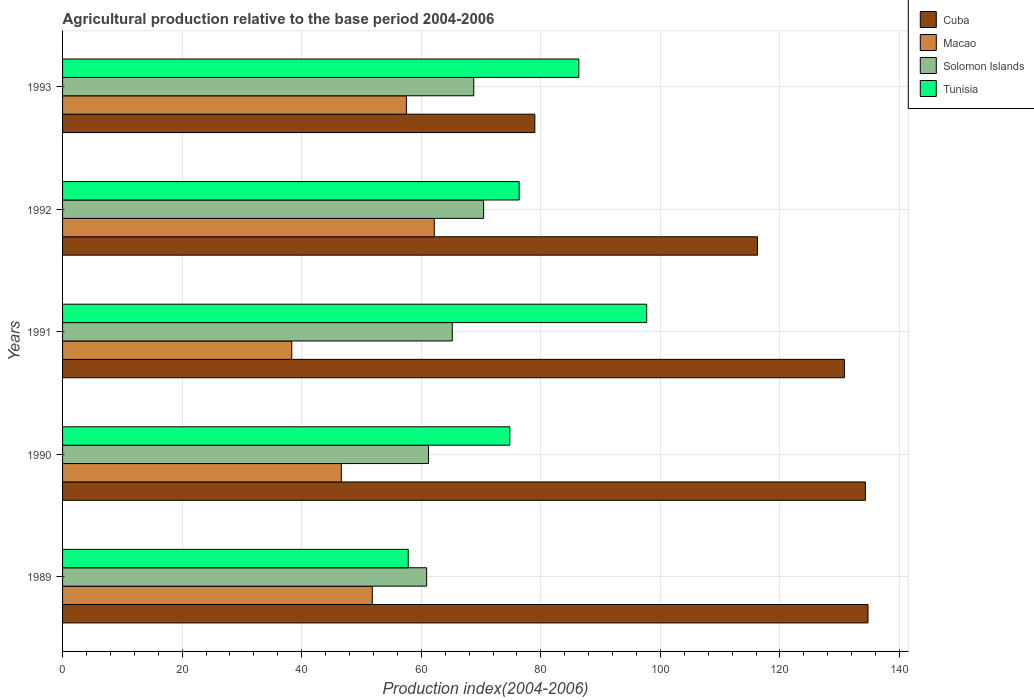Are the number of bars per tick equal to the number of legend labels?
Keep it short and to the point. Yes. Are the number of bars on each tick of the Y-axis equal?
Provide a succinct answer. Yes. How many bars are there on the 5th tick from the top?
Make the answer very short. 4. What is the label of the 3rd group of bars from the top?
Ensure brevity in your answer.  1991. What is the agricultural production index in Macao in 1989?
Give a very brief answer. 51.81. Across all years, what is the maximum agricultural production index in Macao?
Make the answer very short. 62.18. Across all years, what is the minimum agricultural production index in Macao?
Offer a very short reply. 38.34. What is the total agricultural production index in Macao in the graph?
Your answer should be very brief. 256.47. What is the difference between the agricultural production index in Macao in 1990 and that in 1991?
Give a very brief answer. 8.29. What is the difference between the agricultural production index in Cuba in 1990 and the agricultural production index in Tunisia in 1992?
Keep it short and to the point. 57.91. What is the average agricultural production index in Cuba per year?
Give a very brief answer. 119.01. In the year 1993, what is the difference between the agricultural production index in Tunisia and agricultural production index in Cuba?
Provide a succinct answer. 7.36. What is the ratio of the agricultural production index in Cuba in 1991 to that in 1992?
Your response must be concise. 1.13. What is the difference between the highest and the second highest agricultural production index in Tunisia?
Offer a terse response. 11.35. What is the difference between the highest and the lowest agricultural production index in Tunisia?
Offer a very short reply. 39.88. Is it the case that in every year, the sum of the agricultural production index in Tunisia and agricultural production index in Cuba is greater than the sum of agricultural production index in Solomon Islands and agricultural production index in Macao?
Offer a terse response. No. What does the 4th bar from the top in 1993 represents?
Your answer should be very brief. Cuba. What does the 2nd bar from the bottom in 1992 represents?
Your response must be concise. Macao. How many years are there in the graph?
Your answer should be very brief. 5. Are the values on the major ticks of X-axis written in scientific E-notation?
Make the answer very short. No. Does the graph contain any zero values?
Provide a succinct answer. No. Does the graph contain grids?
Your answer should be compact. Yes. What is the title of the graph?
Keep it short and to the point. Agricultural production relative to the base period 2004-2006. Does "Low income" appear as one of the legend labels in the graph?
Your response must be concise. No. What is the label or title of the X-axis?
Provide a succinct answer. Production index(2004-2006). What is the label or title of the Y-axis?
Provide a short and direct response. Years. What is the Production index(2004-2006) in Cuba in 1989?
Make the answer very short. 134.73. What is the Production index(2004-2006) of Macao in 1989?
Your answer should be compact. 51.81. What is the Production index(2004-2006) in Solomon Islands in 1989?
Give a very brief answer. 60.9. What is the Production index(2004-2006) in Tunisia in 1989?
Your answer should be compact. 57.83. What is the Production index(2004-2006) in Cuba in 1990?
Your answer should be very brief. 134.29. What is the Production index(2004-2006) in Macao in 1990?
Your answer should be compact. 46.63. What is the Production index(2004-2006) in Solomon Islands in 1990?
Offer a terse response. 61.21. What is the Production index(2004-2006) of Tunisia in 1990?
Your answer should be very brief. 74.82. What is the Production index(2004-2006) of Cuba in 1991?
Provide a short and direct response. 130.78. What is the Production index(2004-2006) of Macao in 1991?
Keep it short and to the point. 38.34. What is the Production index(2004-2006) in Solomon Islands in 1991?
Offer a very short reply. 65.19. What is the Production index(2004-2006) of Tunisia in 1991?
Your answer should be very brief. 97.71. What is the Production index(2004-2006) of Cuba in 1992?
Provide a short and direct response. 116.24. What is the Production index(2004-2006) in Macao in 1992?
Ensure brevity in your answer.  62.18. What is the Production index(2004-2006) of Solomon Islands in 1992?
Make the answer very short. 70.43. What is the Production index(2004-2006) in Tunisia in 1992?
Provide a succinct answer. 76.38. What is the Production index(2004-2006) of Cuba in 1993?
Give a very brief answer. 79. What is the Production index(2004-2006) in Macao in 1993?
Offer a very short reply. 57.51. What is the Production index(2004-2006) of Solomon Islands in 1993?
Offer a very short reply. 68.78. What is the Production index(2004-2006) in Tunisia in 1993?
Ensure brevity in your answer.  86.36. Across all years, what is the maximum Production index(2004-2006) in Cuba?
Your response must be concise. 134.73. Across all years, what is the maximum Production index(2004-2006) in Macao?
Offer a very short reply. 62.18. Across all years, what is the maximum Production index(2004-2006) of Solomon Islands?
Your response must be concise. 70.43. Across all years, what is the maximum Production index(2004-2006) in Tunisia?
Your response must be concise. 97.71. Across all years, what is the minimum Production index(2004-2006) of Cuba?
Provide a succinct answer. 79. Across all years, what is the minimum Production index(2004-2006) in Macao?
Your response must be concise. 38.34. Across all years, what is the minimum Production index(2004-2006) of Solomon Islands?
Your answer should be very brief. 60.9. Across all years, what is the minimum Production index(2004-2006) of Tunisia?
Your response must be concise. 57.83. What is the total Production index(2004-2006) in Cuba in the graph?
Your response must be concise. 595.04. What is the total Production index(2004-2006) of Macao in the graph?
Ensure brevity in your answer.  256.47. What is the total Production index(2004-2006) of Solomon Islands in the graph?
Give a very brief answer. 326.51. What is the total Production index(2004-2006) in Tunisia in the graph?
Give a very brief answer. 393.1. What is the difference between the Production index(2004-2006) in Cuba in 1989 and that in 1990?
Make the answer very short. 0.44. What is the difference between the Production index(2004-2006) of Macao in 1989 and that in 1990?
Provide a succinct answer. 5.18. What is the difference between the Production index(2004-2006) of Solomon Islands in 1989 and that in 1990?
Your response must be concise. -0.31. What is the difference between the Production index(2004-2006) in Tunisia in 1989 and that in 1990?
Provide a short and direct response. -16.99. What is the difference between the Production index(2004-2006) of Cuba in 1989 and that in 1991?
Offer a very short reply. 3.95. What is the difference between the Production index(2004-2006) in Macao in 1989 and that in 1991?
Ensure brevity in your answer.  13.47. What is the difference between the Production index(2004-2006) of Solomon Islands in 1989 and that in 1991?
Offer a terse response. -4.29. What is the difference between the Production index(2004-2006) of Tunisia in 1989 and that in 1991?
Your response must be concise. -39.88. What is the difference between the Production index(2004-2006) of Cuba in 1989 and that in 1992?
Make the answer very short. 18.49. What is the difference between the Production index(2004-2006) in Macao in 1989 and that in 1992?
Give a very brief answer. -10.37. What is the difference between the Production index(2004-2006) of Solomon Islands in 1989 and that in 1992?
Make the answer very short. -9.53. What is the difference between the Production index(2004-2006) in Tunisia in 1989 and that in 1992?
Keep it short and to the point. -18.55. What is the difference between the Production index(2004-2006) of Cuba in 1989 and that in 1993?
Make the answer very short. 55.73. What is the difference between the Production index(2004-2006) of Solomon Islands in 1989 and that in 1993?
Provide a succinct answer. -7.88. What is the difference between the Production index(2004-2006) of Tunisia in 1989 and that in 1993?
Make the answer very short. -28.53. What is the difference between the Production index(2004-2006) in Cuba in 1990 and that in 1991?
Your response must be concise. 3.51. What is the difference between the Production index(2004-2006) in Macao in 1990 and that in 1991?
Offer a very short reply. 8.29. What is the difference between the Production index(2004-2006) in Solomon Islands in 1990 and that in 1991?
Your answer should be compact. -3.98. What is the difference between the Production index(2004-2006) of Tunisia in 1990 and that in 1991?
Offer a terse response. -22.89. What is the difference between the Production index(2004-2006) in Cuba in 1990 and that in 1992?
Ensure brevity in your answer.  18.05. What is the difference between the Production index(2004-2006) in Macao in 1990 and that in 1992?
Give a very brief answer. -15.55. What is the difference between the Production index(2004-2006) of Solomon Islands in 1990 and that in 1992?
Provide a succinct answer. -9.22. What is the difference between the Production index(2004-2006) of Tunisia in 1990 and that in 1992?
Your answer should be very brief. -1.56. What is the difference between the Production index(2004-2006) of Cuba in 1990 and that in 1993?
Make the answer very short. 55.29. What is the difference between the Production index(2004-2006) of Macao in 1990 and that in 1993?
Keep it short and to the point. -10.88. What is the difference between the Production index(2004-2006) in Solomon Islands in 1990 and that in 1993?
Ensure brevity in your answer.  -7.57. What is the difference between the Production index(2004-2006) in Tunisia in 1990 and that in 1993?
Make the answer very short. -11.54. What is the difference between the Production index(2004-2006) in Cuba in 1991 and that in 1992?
Offer a very short reply. 14.54. What is the difference between the Production index(2004-2006) in Macao in 1991 and that in 1992?
Provide a succinct answer. -23.84. What is the difference between the Production index(2004-2006) of Solomon Islands in 1991 and that in 1992?
Your answer should be very brief. -5.24. What is the difference between the Production index(2004-2006) of Tunisia in 1991 and that in 1992?
Keep it short and to the point. 21.33. What is the difference between the Production index(2004-2006) of Cuba in 1991 and that in 1993?
Provide a succinct answer. 51.78. What is the difference between the Production index(2004-2006) of Macao in 1991 and that in 1993?
Give a very brief answer. -19.17. What is the difference between the Production index(2004-2006) in Solomon Islands in 1991 and that in 1993?
Your answer should be compact. -3.59. What is the difference between the Production index(2004-2006) in Tunisia in 1991 and that in 1993?
Ensure brevity in your answer.  11.35. What is the difference between the Production index(2004-2006) of Cuba in 1992 and that in 1993?
Provide a short and direct response. 37.24. What is the difference between the Production index(2004-2006) in Macao in 1992 and that in 1993?
Keep it short and to the point. 4.67. What is the difference between the Production index(2004-2006) in Solomon Islands in 1992 and that in 1993?
Your answer should be very brief. 1.65. What is the difference between the Production index(2004-2006) in Tunisia in 1992 and that in 1993?
Give a very brief answer. -9.98. What is the difference between the Production index(2004-2006) of Cuba in 1989 and the Production index(2004-2006) of Macao in 1990?
Give a very brief answer. 88.1. What is the difference between the Production index(2004-2006) in Cuba in 1989 and the Production index(2004-2006) in Solomon Islands in 1990?
Provide a short and direct response. 73.52. What is the difference between the Production index(2004-2006) of Cuba in 1989 and the Production index(2004-2006) of Tunisia in 1990?
Your response must be concise. 59.91. What is the difference between the Production index(2004-2006) of Macao in 1989 and the Production index(2004-2006) of Solomon Islands in 1990?
Make the answer very short. -9.4. What is the difference between the Production index(2004-2006) in Macao in 1989 and the Production index(2004-2006) in Tunisia in 1990?
Offer a very short reply. -23.01. What is the difference between the Production index(2004-2006) in Solomon Islands in 1989 and the Production index(2004-2006) in Tunisia in 1990?
Ensure brevity in your answer.  -13.92. What is the difference between the Production index(2004-2006) in Cuba in 1989 and the Production index(2004-2006) in Macao in 1991?
Make the answer very short. 96.39. What is the difference between the Production index(2004-2006) in Cuba in 1989 and the Production index(2004-2006) in Solomon Islands in 1991?
Offer a very short reply. 69.54. What is the difference between the Production index(2004-2006) of Cuba in 1989 and the Production index(2004-2006) of Tunisia in 1991?
Give a very brief answer. 37.02. What is the difference between the Production index(2004-2006) of Macao in 1989 and the Production index(2004-2006) of Solomon Islands in 1991?
Ensure brevity in your answer.  -13.38. What is the difference between the Production index(2004-2006) of Macao in 1989 and the Production index(2004-2006) of Tunisia in 1991?
Provide a succinct answer. -45.9. What is the difference between the Production index(2004-2006) in Solomon Islands in 1989 and the Production index(2004-2006) in Tunisia in 1991?
Offer a terse response. -36.81. What is the difference between the Production index(2004-2006) in Cuba in 1989 and the Production index(2004-2006) in Macao in 1992?
Your answer should be very brief. 72.55. What is the difference between the Production index(2004-2006) in Cuba in 1989 and the Production index(2004-2006) in Solomon Islands in 1992?
Keep it short and to the point. 64.3. What is the difference between the Production index(2004-2006) in Cuba in 1989 and the Production index(2004-2006) in Tunisia in 1992?
Your answer should be compact. 58.35. What is the difference between the Production index(2004-2006) in Macao in 1989 and the Production index(2004-2006) in Solomon Islands in 1992?
Your answer should be very brief. -18.62. What is the difference between the Production index(2004-2006) of Macao in 1989 and the Production index(2004-2006) of Tunisia in 1992?
Your response must be concise. -24.57. What is the difference between the Production index(2004-2006) of Solomon Islands in 1989 and the Production index(2004-2006) of Tunisia in 1992?
Provide a short and direct response. -15.48. What is the difference between the Production index(2004-2006) in Cuba in 1989 and the Production index(2004-2006) in Macao in 1993?
Your response must be concise. 77.22. What is the difference between the Production index(2004-2006) in Cuba in 1989 and the Production index(2004-2006) in Solomon Islands in 1993?
Make the answer very short. 65.95. What is the difference between the Production index(2004-2006) in Cuba in 1989 and the Production index(2004-2006) in Tunisia in 1993?
Ensure brevity in your answer.  48.37. What is the difference between the Production index(2004-2006) of Macao in 1989 and the Production index(2004-2006) of Solomon Islands in 1993?
Keep it short and to the point. -16.97. What is the difference between the Production index(2004-2006) of Macao in 1989 and the Production index(2004-2006) of Tunisia in 1993?
Your answer should be compact. -34.55. What is the difference between the Production index(2004-2006) in Solomon Islands in 1989 and the Production index(2004-2006) in Tunisia in 1993?
Your answer should be very brief. -25.46. What is the difference between the Production index(2004-2006) of Cuba in 1990 and the Production index(2004-2006) of Macao in 1991?
Provide a succinct answer. 95.95. What is the difference between the Production index(2004-2006) of Cuba in 1990 and the Production index(2004-2006) of Solomon Islands in 1991?
Keep it short and to the point. 69.1. What is the difference between the Production index(2004-2006) in Cuba in 1990 and the Production index(2004-2006) in Tunisia in 1991?
Your response must be concise. 36.58. What is the difference between the Production index(2004-2006) in Macao in 1990 and the Production index(2004-2006) in Solomon Islands in 1991?
Offer a terse response. -18.56. What is the difference between the Production index(2004-2006) of Macao in 1990 and the Production index(2004-2006) of Tunisia in 1991?
Provide a succinct answer. -51.08. What is the difference between the Production index(2004-2006) in Solomon Islands in 1990 and the Production index(2004-2006) in Tunisia in 1991?
Provide a succinct answer. -36.5. What is the difference between the Production index(2004-2006) in Cuba in 1990 and the Production index(2004-2006) in Macao in 1992?
Give a very brief answer. 72.11. What is the difference between the Production index(2004-2006) in Cuba in 1990 and the Production index(2004-2006) in Solomon Islands in 1992?
Provide a short and direct response. 63.86. What is the difference between the Production index(2004-2006) of Cuba in 1990 and the Production index(2004-2006) of Tunisia in 1992?
Keep it short and to the point. 57.91. What is the difference between the Production index(2004-2006) of Macao in 1990 and the Production index(2004-2006) of Solomon Islands in 1992?
Offer a very short reply. -23.8. What is the difference between the Production index(2004-2006) of Macao in 1990 and the Production index(2004-2006) of Tunisia in 1992?
Provide a succinct answer. -29.75. What is the difference between the Production index(2004-2006) of Solomon Islands in 1990 and the Production index(2004-2006) of Tunisia in 1992?
Provide a succinct answer. -15.17. What is the difference between the Production index(2004-2006) in Cuba in 1990 and the Production index(2004-2006) in Macao in 1993?
Provide a succinct answer. 76.78. What is the difference between the Production index(2004-2006) of Cuba in 1990 and the Production index(2004-2006) of Solomon Islands in 1993?
Offer a terse response. 65.51. What is the difference between the Production index(2004-2006) in Cuba in 1990 and the Production index(2004-2006) in Tunisia in 1993?
Ensure brevity in your answer.  47.93. What is the difference between the Production index(2004-2006) of Macao in 1990 and the Production index(2004-2006) of Solomon Islands in 1993?
Your response must be concise. -22.15. What is the difference between the Production index(2004-2006) of Macao in 1990 and the Production index(2004-2006) of Tunisia in 1993?
Give a very brief answer. -39.73. What is the difference between the Production index(2004-2006) in Solomon Islands in 1990 and the Production index(2004-2006) in Tunisia in 1993?
Keep it short and to the point. -25.15. What is the difference between the Production index(2004-2006) in Cuba in 1991 and the Production index(2004-2006) in Macao in 1992?
Give a very brief answer. 68.6. What is the difference between the Production index(2004-2006) in Cuba in 1991 and the Production index(2004-2006) in Solomon Islands in 1992?
Give a very brief answer. 60.35. What is the difference between the Production index(2004-2006) in Cuba in 1991 and the Production index(2004-2006) in Tunisia in 1992?
Provide a succinct answer. 54.4. What is the difference between the Production index(2004-2006) of Macao in 1991 and the Production index(2004-2006) of Solomon Islands in 1992?
Your answer should be compact. -32.09. What is the difference between the Production index(2004-2006) of Macao in 1991 and the Production index(2004-2006) of Tunisia in 1992?
Offer a very short reply. -38.04. What is the difference between the Production index(2004-2006) in Solomon Islands in 1991 and the Production index(2004-2006) in Tunisia in 1992?
Make the answer very short. -11.19. What is the difference between the Production index(2004-2006) in Cuba in 1991 and the Production index(2004-2006) in Macao in 1993?
Ensure brevity in your answer.  73.27. What is the difference between the Production index(2004-2006) of Cuba in 1991 and the Production index(2004-2006) of Solomon Islands in 1993?
Provide a short and direct response. 62. What is the difference between the Production index(2004-2006) of Cuba in 1991 and the Production index(2004-2006) of Tunisia in 1993?
Provide a succinct answer. 44.42. What is the difference between the Production index(2004-2006) in Macao in 1991 and the Production index(2004-2006) in Solomon Islands in 1993?
Your response must be concise. -30.44. What is the difference between the Production index(2004-2006) of Macao in 1991 and the Production index(2004-2006) of Tunisia in 1993?
Offer a very short reply. -48.02. What is the difference between the Production index(2004-2006) in Solomon Islands in 1991 and the Production index(2004-2006) in Tunisia in 1993?
Give a very brief answer. -21.17. What is the difference between the Production index(2004-2006) in Cuba in 1992 and the Production index(2004-2006) in Macao in 1993?
Your response must be concise. 58.73. What is the difference between the Production index(2004-2006) in Cuba in 1992 and the Production index(2004-2006) in Solomon Islands in 1993?
Your answer should be very brief. 47.46. What is the difference between the Production index(2004-2006) of Cuba in 1992 and the Production index(2004-2006) of Tunisia in 1993?
Provide a short and direct response. 29.88. What is the difference between the Production index(2004-2006) in Macao in 1992 and the Production index(2004-2006) in Solomon Islands in 1993?
Your answer should be very brief. -6.6. What is the difference between the Production index(2004-2006) in Macao in 1992 and the Production index(2004-2006) in Tunisia in 1993?
Your answer should be very brief. -24.18. What is the difference between the Production index(2004-2006) of Solomon Islands in 1992 and the Production index(2004-2006) of Tunisia in 1993?
Ensure brevity in your answer.  -15.93. What is the average Production index(2004-2006) of Cuba per year?
Your answer should be very brief. 119.01. What is the average Production index(2004-2006) of Macao per year?
Offer a terse response. 51.29. What is the average Production index(2004-2006) in Solomon Islands per year?
Offer a very short reply. 65.3. What is the average Production index(2004-2006) in Tunisia per year?
Make the answer very short. 78.62. In the year 1989, what is the difference between the Production index(2004-2006) in Cuba and Production index(2004-2006) in Macao?
Your response must be concise. 82.92. In the year 1989, what is the difference between the Production index(2004-2006) of Cuba and Production index(2004-2006) of Solomon Islands?
Your answer should be compact. 73.83. In the year 1989, what is the difference between the Production index(2004-2006) in Cuba and Production index(2004-2006) in Tunisia?
Offer a terse response. 76.9. In the year 1989, what is the difference between the Production index(2004-2006) in Macao and Production index(2004-2006) in Solomon Islands?
Provide a short and direct response. -9.09. In the year 1989, what is the difference between the Production index(2004-2006) in Macao and Production index(2004-2006) in Tunisia?
Offer a very short reply. -6.02. In the year 1989, what is the difference between the Production index(2004-2006) in Solomon Islands and Production index(2004-2006) in Tunisia?
Your answer should be compact. 3.07. In the year 1990, what is the difference between the Production index(2004-2006) of Cuba and Production index(2004-2006) of Macao?
Ensure brevity in your answer.  87.66. In the year 1990, what is the difference between the Production index(2004-2006) in Cuba and Production index(2004-2006) in Solomon Islands?
Provide a succinct answer. 73.08. In the year 1990, what is the difference between the Production index(2004-2006) in Cuba and Production index(2004-2006) in Tunisia?
Offer a terse response. 59.47. In the year 1990, what is the difference between the Production index(2004-2006) of Macao and Production index(2004-2006) of Solomon Islands?
Provide a short and direct response. -14.58. In the year 1990, what is the difference between the Production index(2004-2006) of Macao and Production index(2004-2006) of Tunisia?
Give a very brief answer. -28.19. In the year 1990, what is the difference between the Production index(2004-2006) of Solomon Islands and Production index(2004-2006) of Tunisia?
Ensure brevity in your answer.  -13.61. In the year 1991, what is the difference between the Production index(2004-2006) in Cuba and Production index(2004-2006) in Macao?
Offer a very short reply. 92.44. In the year 1991, what is the difference between the Production index(2004-2006) of Cuba and Production index(2004-2006) of Solomon Islands?
Keep it short and to the point. 65.59. In the year 1991, what is the difference between the Production index(2004-2006) of Cuba and Production index(2004-2006) of Tunisia?
Offer a terse response. 33.07. In the year 1991, what is the difference between the Production index(2004-2006) in Macao and Production index(2004-2006) in Solomon Islands?
Your response must be concise. -26.85. In the year 1991, what is the difference between the Production index(2004-2006) of Macao and Production index(2004-2006) of Tunisia?
Your answer should be compact. -59.37. In the year 1991, what is the difference between the Production index(2004-2006) in Solomon Islands and Production index(2004-2006) in Tunisia?
Your answer should be very brief. -32.52. In the year 1992, what is the difference between the Production index(2004-2006) in Cuba and Production index(2004-2006) in Macao?
Provide a succinct answer. 54.06. In the year 1992, what is the difference between the Production index(2004-2006) of Cuba and Production index(2004-2006) of Solomon Islands?
Your answer should be compact. 45.81. In the year 1992, what is the difference between the Production index(2004-2006) of Cuba and Production index(2004-2006) of Tunisia?
Your answer should be very brief. 39.86. In the year 1992, what is the difference between the Production index(2004-2006) in Macao and Production index(2004-2006) in Solomon Islands?
Make the answer very short. -8.25. In the year 1992, what is the difference between the Production index(2004-2006) of Solomon Islands and Production index(2004-2006) of Tunisia?
Offer a terse response. -5.95. In the year 1993, what is the difference between the Production index(2004-2006) in Cuba and Production index(2004-2006) in Macao?
Give a very brief answer. 21.49. In the year 1993, what is the difference between the Production index(2004-2006) in Cuba and Production index(2004-2006) in Solomon Islands?
Offer a very short reply. 10.22. In the year 1993, what is the difference between the Production index(2004-2006) in Cuba and Production index(2004-2006) in Tunisia?
Your answer should be very brief. -7.36. In the year 1993, what is the difference between the Production index(2004-2006) of Macao and Production index(2004-2006) of Solomon Islands?
Your answer should be compact. -11.27. In the year 1993, what is the difference between the Production index(2004-2006) of Macao and Production index(2004-2006) of Tunisia?
Your answer should be compact. -28.85. In the year 1993, what is the difference between the Production index(2004-2006) in Solomon Islands and Production index(2004-2006) in Tunisia?
Provide a short and direct response. -17.58. What is the ratio of the Production index(2004-2006) in Cuba in 1989 to that in 1990?
Make the answer very short. 1. What is the ratio of the Production index(2004-2006) of Tunisia in 1989 to that in 1990?
Your answer should be very brief. 0.77. What is the ratio of the Production index(2004-2006) in Cuba in 1989 to that in 1991?
Offer a terse response. 1.03. What is the ratio of the Production index(2004-2006) in Macao in 1989 to that in 1991?
Your answer should be very brief. 1.35. What is the ratio of the Production index(2004-2006) in Solomon Islands in 1989 to that in 1991?
Keep it short and to the point. 0.93. What is the ratio of the Production index(2004-2006) of Tunisia in 1989 to that in 1991?
Your answer should be compact. 0.59. What is the ratio of the Production index(2004-2006) of Cuba in 1989 to that in 1992?
Offer a terse response. 1.16. What is the ratio of the Production index(2004-2006) of Macao in 1989 to that in 1992?
Offer a very short reply. 0.83. What is the ratio of the Production index(2004-2006) in Solomon Islands in 1989 to that in 1992?
Provide a succinct answer. 0.86. What is the ratio of the Production index(2004-2006) of Tunisia in 1989 to that in 1992?
Offer a terse response. 0.76. What is the ratio of the Production index(2004-2006) in Cuba in 1989 to that in 1993?
Your response must be concise. 1.71. What is the ratio of the Production index(2004-2006) in Macao in 1989 to that in 1993?
Offer a terse response. 0.9. What is the ratio of the Production index(2004-2006) of Solomon Islands in 1989 to that in 1993?
Keep it short and to the point. 0.89. What is the ratio of the Production index(2004-2006) in Tunisia in 1989 to that in 1993?
Provide a succinct answer. 0.67. What is the ratio of the Production index(2004-2006) in Cuba in 1990 to that in 1991?
Keep it short and to the point. 1.03. What is the ratio of the Production index(2004-2006) in Macao in 1990 to that in 1991?
Make the answer very short. 1.22. What is the ratio of the Production index(2004-2006) of Solomon Islands in 1990 to that in 1991?
Offer a very short reply. 0.94. What is the ratio of the Production index(2004-2006) of Tunisia in 1990 to that in 1991?
Offer a very short reply. 0.77. What is the ratio of the Production index(2004-2006) of Cuba in 1990 to that in 1992?
Give a very brief answer. 1.16. What is the ratio of the Production index(2004-2006) in Macao in 1990 to that in 1992?
Keep it short and to the point. 0.75. What is the ratio of the Production index(2004-2006) of Solomon Islands in 1990 to that in 1992?
Provide a succinct answer. 0.87. What is the ratio of the Production index(2004-2006) of Tunisia in 1990 to that in 1992?
Your answer should be compact. 0.98. What is the ratio of the Production index(2004-2006) in Cuba in 1990 to that in 1993?
Give a very brief answer. 1.7. What is the ratio of the Production index(2004-2006) in Macao in 1990 to that in 1993?
Provide a short and direct response. 0.81. What is the ratio of the Production index(2004-2006) of Solomon Islands in 1990 to that in 1993?
Give a very brief answer. 0.89. What is the ratio of the Production index(2004-2006) in Tunisia in 1990 to that in 1993?
Your response must be concise. 0.87. What is the ratio of the Production index(2004-2006) of Cuba in 1991 to that in 1992?
Provide a short and direct response. 1.13. What is the ratio of the Production index(2004-2006) in Macao in 1991 to that in 1992?
Your answer should be compact. 0.62. What is the ratio of the Production index(2004-2006) in Solomon Islands in 1991 to that in 1992?
Provide a short and direct response. 0.93. What is the ratio of the Production index(2004-2006) of Tunisia in 1991 to that in 1992?
Provide a short and direct response. 1.28. What is the ratio of the Production index(2004-2006) of Cuba in 1991 to that in 1993?
Keep it short and to the point. 1.66. What is the ratio of the Production index(2004-2006) in Solomon Islands in 1991 to that in 1993?
Make the answer very short. 0.95. What is the ratio of the Production index(2004-2006) in Tunisia in 1991 to that in 1993?
Provide a succinct answer. 1.13. What is the ratio of the Production index(2004-2006) in Cuba in 1992 to that in 1993?
Make the answer very short. 1.47. What is the ratio of the Production index(2004-2006) of Macao in 1992 to that in 1993?
Provide a succinct answer. 1.08. What is the ratio of the Production index(2004-2006) of Tunisia in 1992 to that in 1993?
Your answer should be very brief. 0.88. What is the difference between the highest and the second highest Production index(2004-2006) of Cuba?
Give a very brief answer. 0.44. What is the difference between the highest and the second highest Production index(2004-2006) in Macao?
Make the answer very short. 4.67. What is the difference between the highest and the second highest Production index(2004-2006) in Solomon Islands?
Make the answer very short. 1.65. What is the difference between the highest and the second highest Production index(2004-2006) of Tunisia?
Make the answer very short. 11.35. What is the difference between the highest and the lowest Production index(2004-2006) in Cuba?
Ensure brevity in your answer.  55.73. What is the difference between the highest and the lowest Production index(2004-2006) in Macao?
Provide a succinct answer. 23.84. What is the difference between the highest and the lowest Production index(2004-2006) of Solomon Islands?
Provide a succinct answer. 9.53. What is the difference between the highest and the lowest Production index(2004-2006) of Tunisia?
Provide a succinct answer. 39.88. 